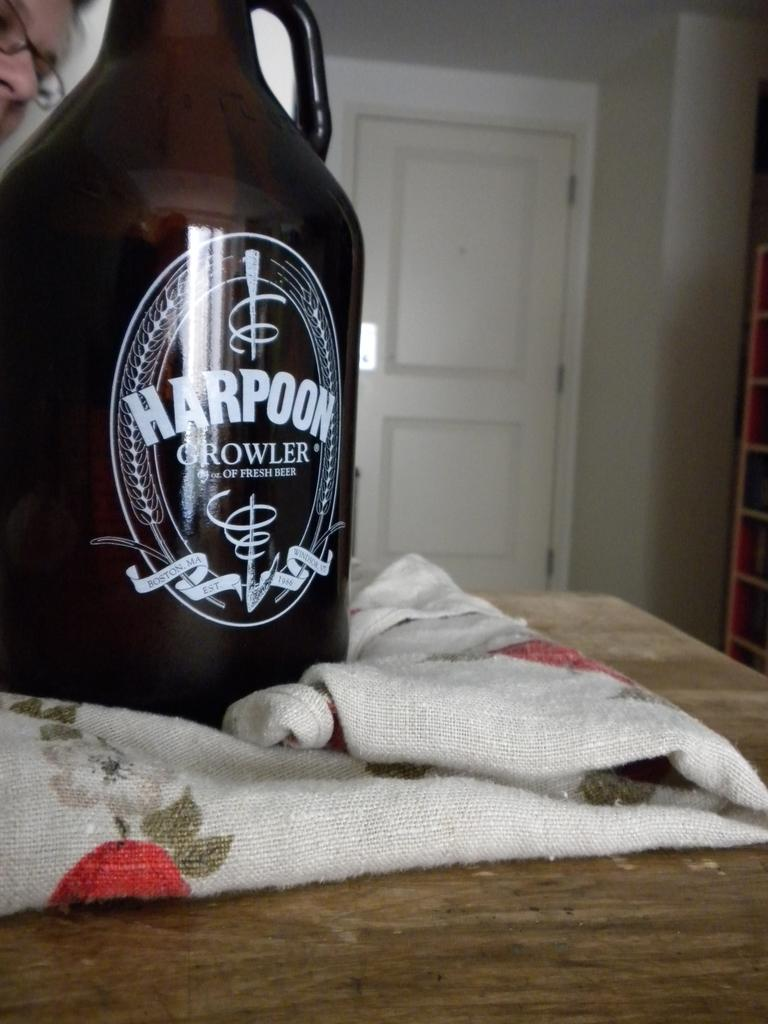Provide a one-sentence caption for the provided image. bottle of alcohol called harpoon growler on the table. 